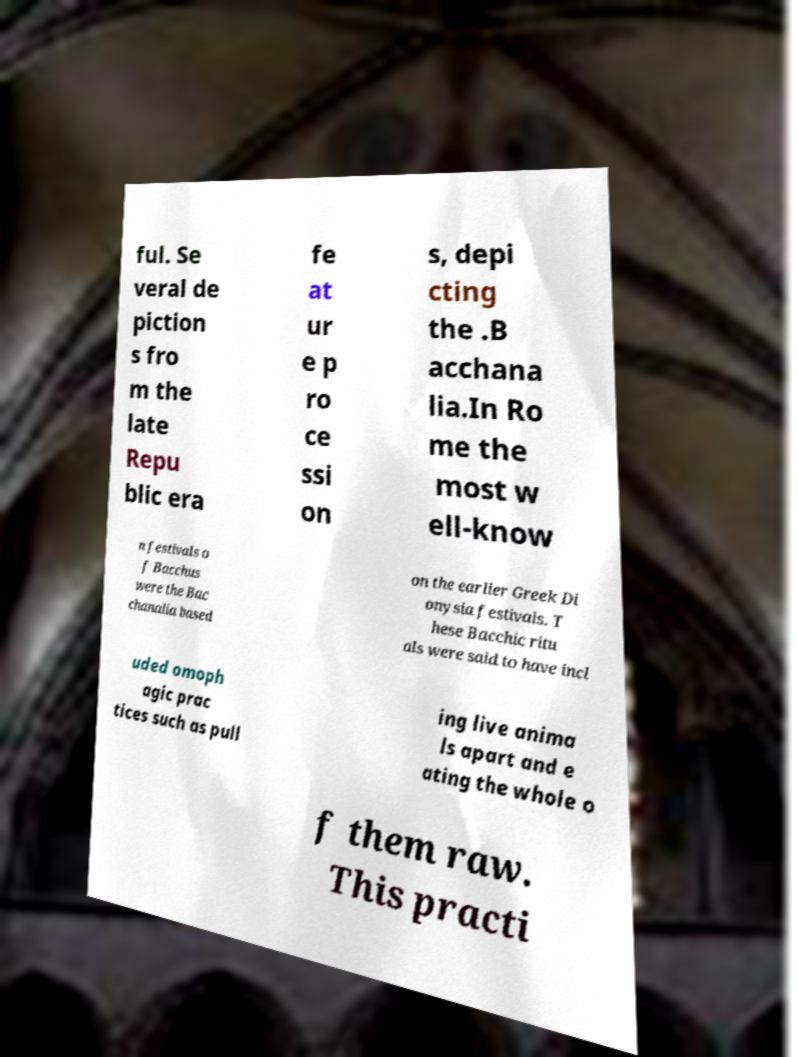Can you read and provide the text displayed in the image?This photo seems to have some interesting text. Can you extract and type it out for me? ful. Se veral de piction s fro m the late Repu blic era fe at ur e p ro ce ssi on s, depi cting the .B acchana lia.In Ro me the most w ell-know n festivals o f Bacchus were the Bac chanalia based on the earlier Greek Di onysia festivals. T hese Bacchic ritu als were said to have incl uded omoph agic prac tices such as pull ing live anima ls apart and e ating the whole o f them raw. This practi 